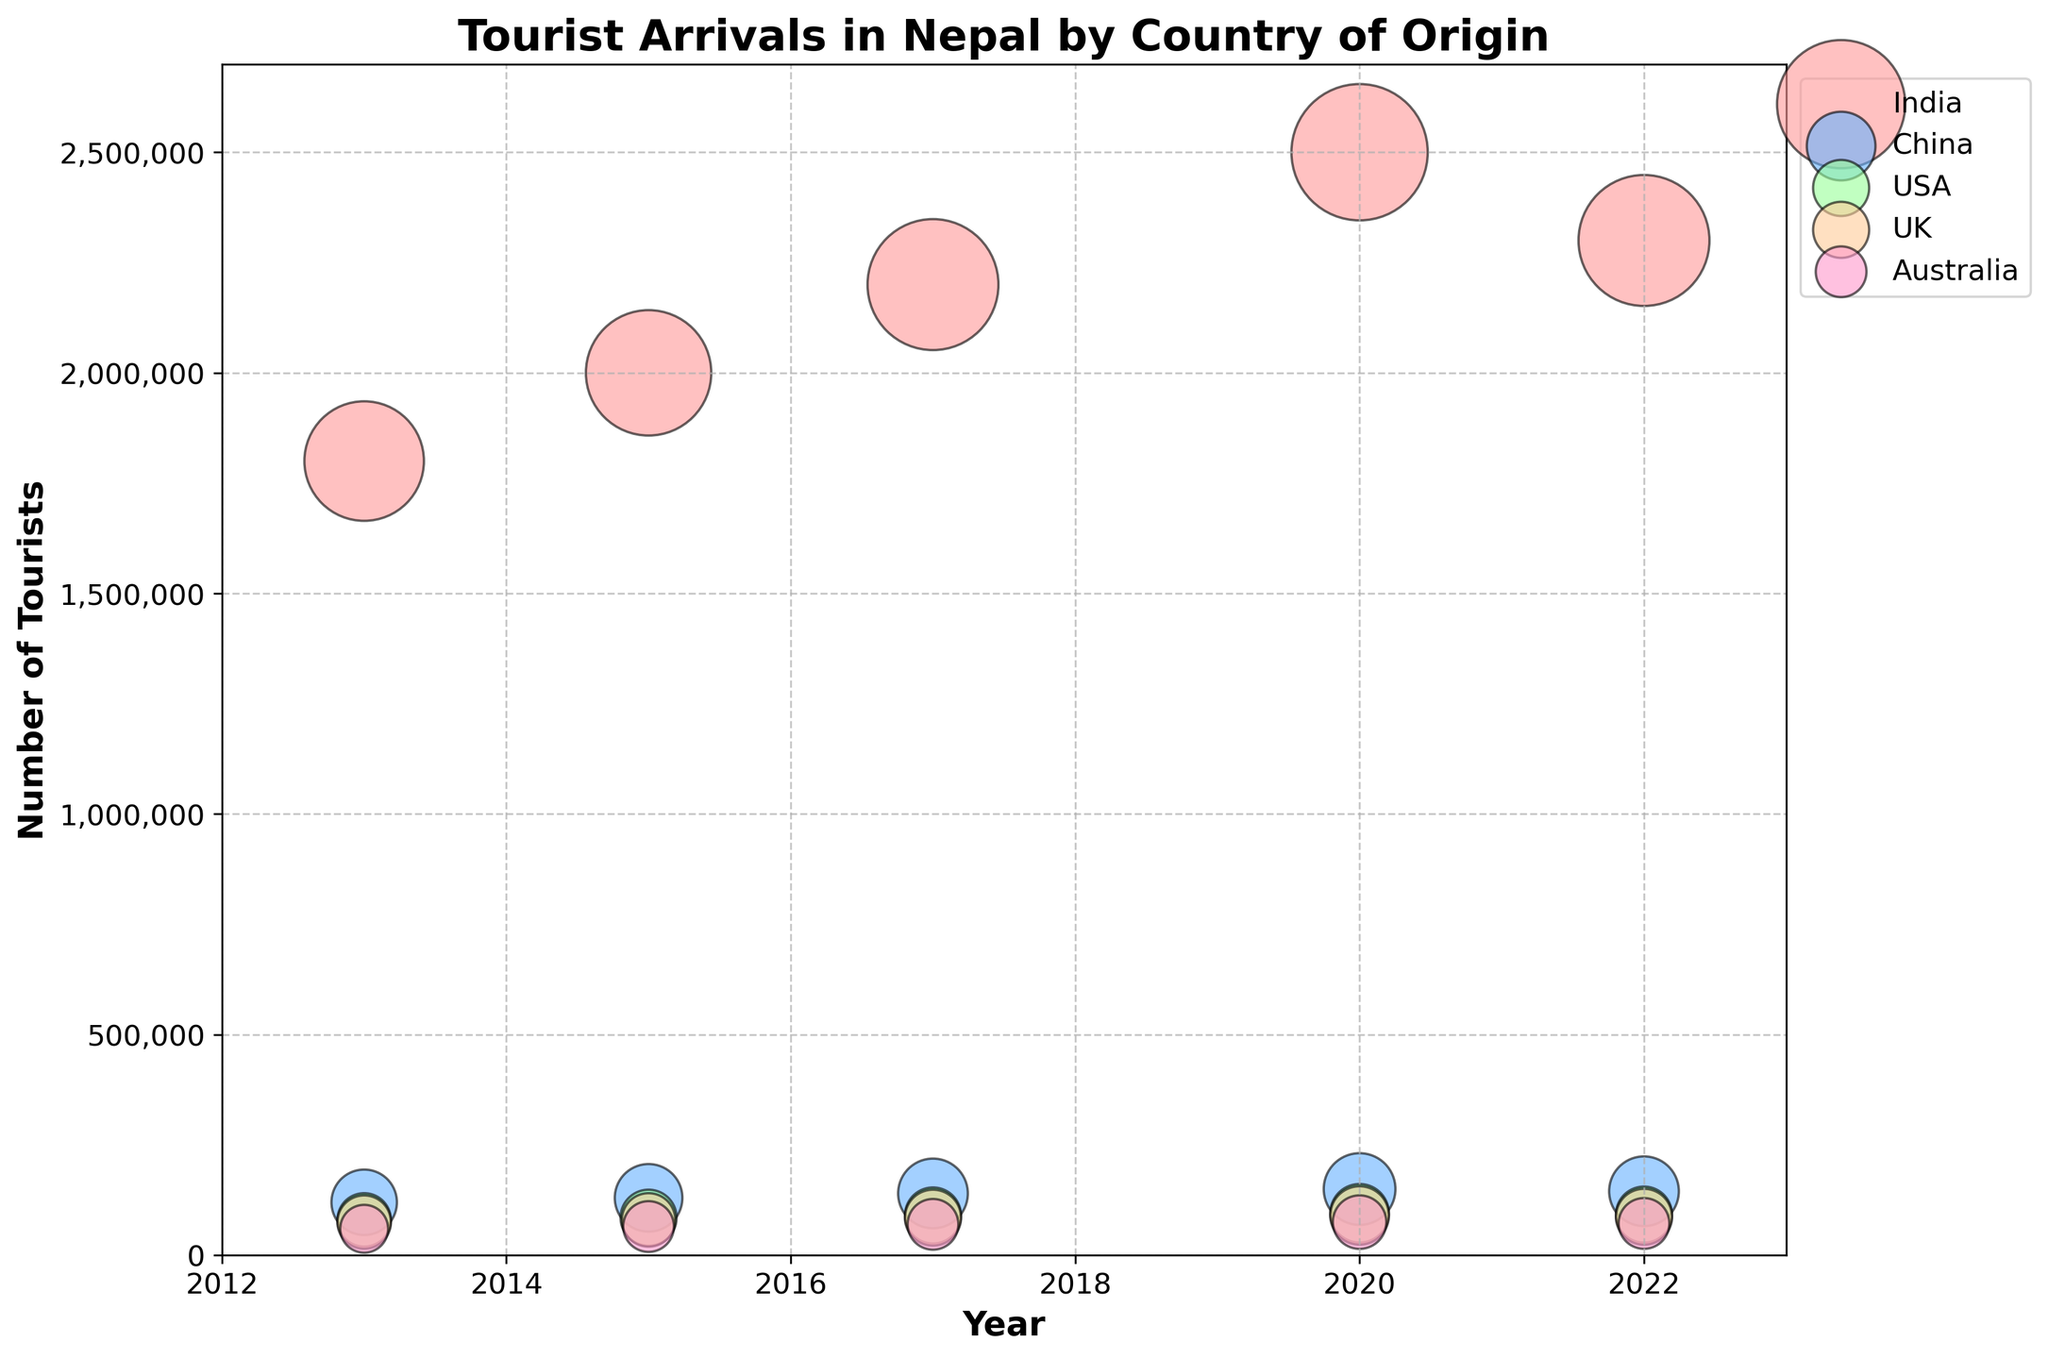What is the title of the figure? The title is located at the top-center of the figure and is in a larger, bold font for visibility.
Answer: Tourist Arrivals in Nepal by Country of Origin What is the value shown on the y-axis for 2020 for the country with the highest tourist arrivals? The country with the highest tourist arrivals can be seen from the largest bubble in that year, labeled to the left or right of the bubble. Verify by the bubble size.
Answer: 2,500,000 Which country had the smallest number of tourists in 2013 according to the chart? Check for the smallest bubble in 2013 and confirm with its label.
Answer: Australia By how much did the number of tourists from China increase from 2013 to 2020? Subtract the 2013 value from the 2020 value for China.
Answer: 30,000 Which country showed a consistent increase in the number of tourists every year? Identify the country where the bubble size increases progressively for each year in the chart.
Answer: India In which year did the USA have the highest number of tourists arriving in Nepal? Look for the largest bubble size for the USA across the time period and note the year associated with that bubble.
Answer: 2020 Approximately, which country had a relatively flat trend in tourist arrivals between 2013 and 2022? Observe the trend lines for each country's bubbles to see which showed little change over the years.
Answer: Australia Were tourist arrivals from the UK higher or lower in 2015 compared to 2017? Compare the position of the UK bubble between the years 2015 and 2017 in terms of height on the y-axis.
Answer: Lower What was the main trend in tourist arrivals from India from 2013 to 2022? Examine the progression of India’s bubbles across years to determine the general direction (increase, decrease, or stable).
Answer: Increasing What is the transparency level of the bubbles in the chart? All bubbles have the same transparency level, visually confirmed by their consistent shade.
Answer: 0.5 